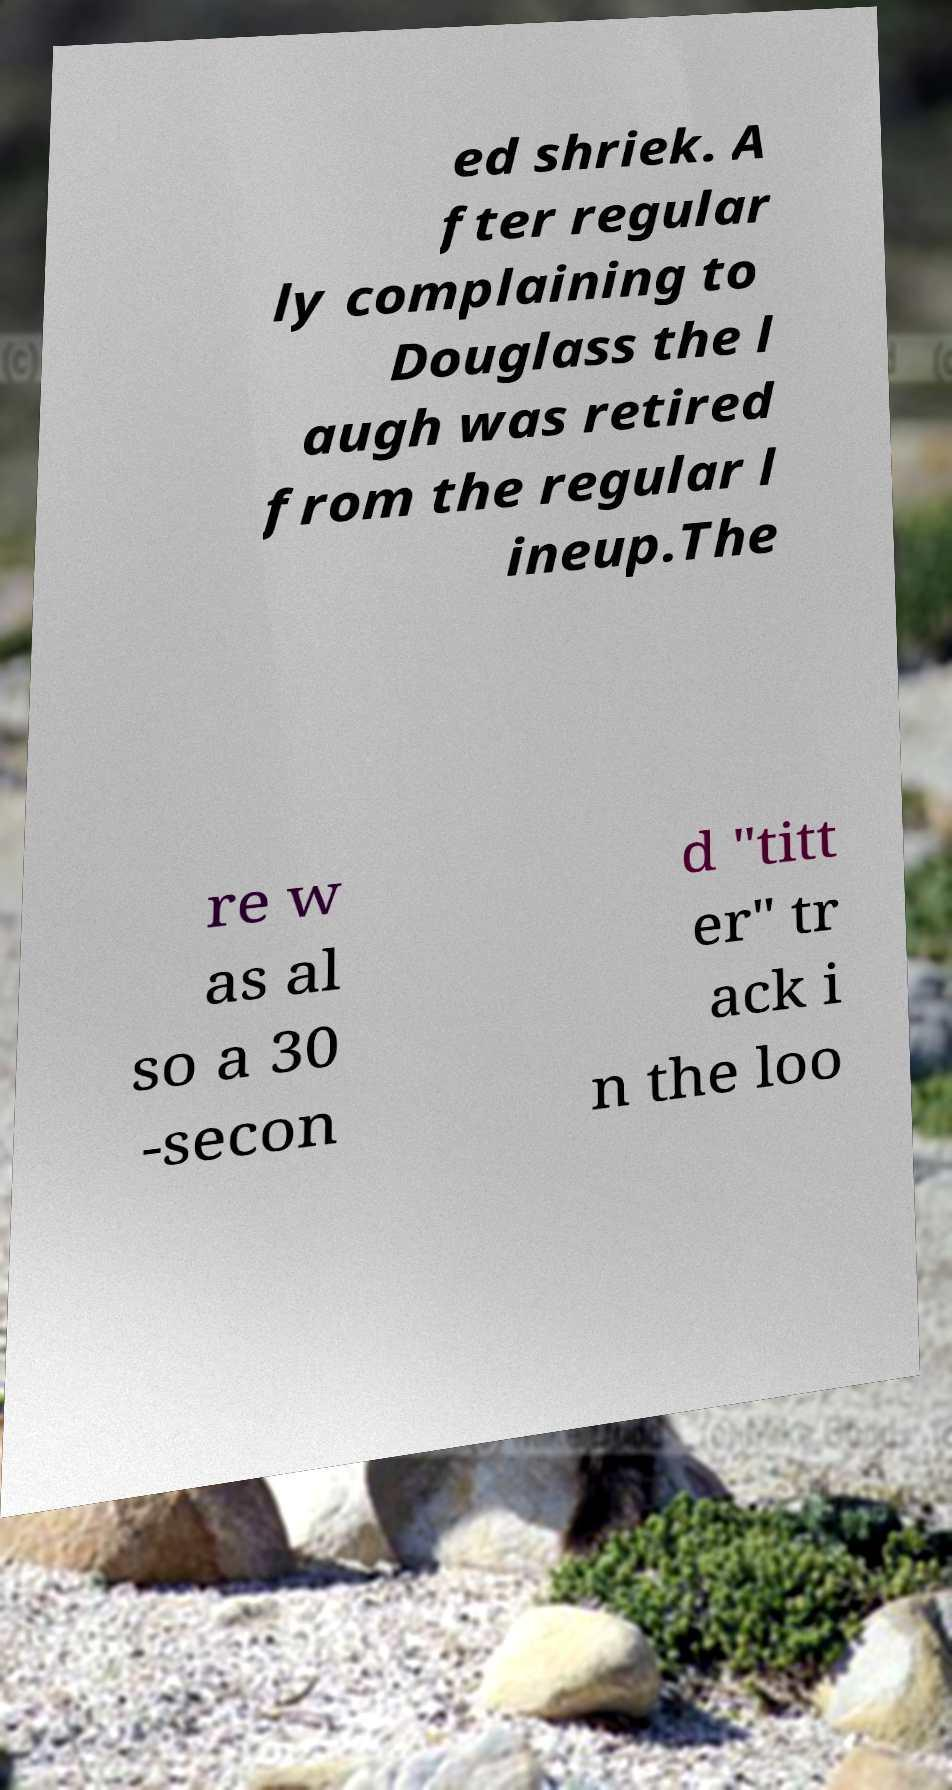Please read and relay the text visible in this image. What does it say? ed shriek. A fter regular ly complaining to Douglass the l augh was retired from the regular l ineup.The re w as al so a 30 -secon d "titt er" tr ack i n the loo 